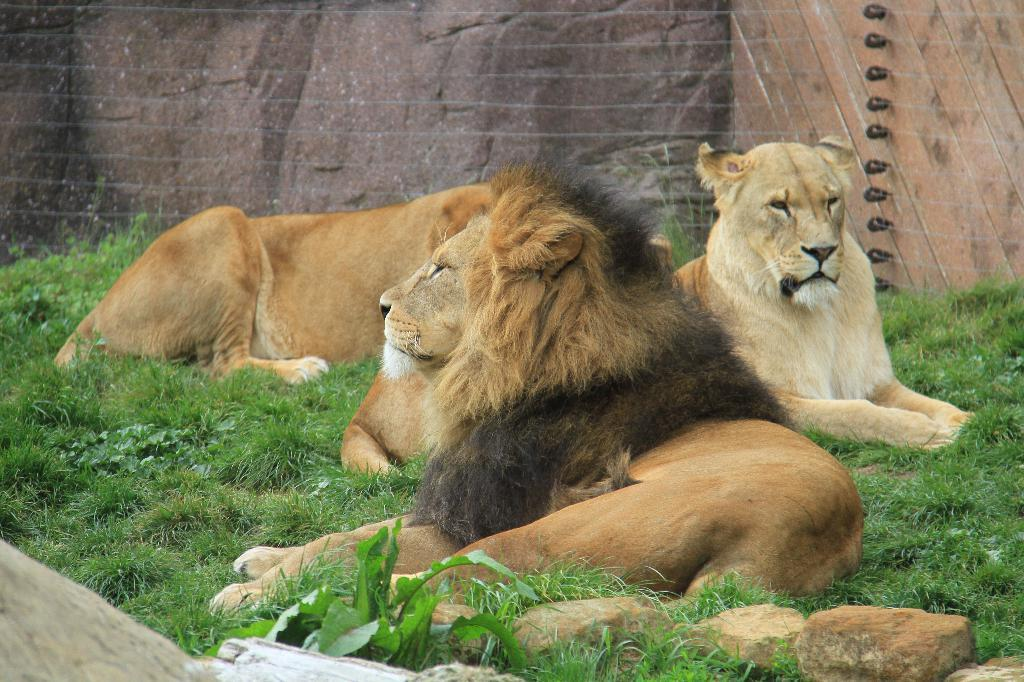What animals are in the center of the image? There are lions in the center of the image. What is the lions' location in relation to the ground? The lions are on the grass. What can be seen in the background of the image? There is a wall in the background of the image. What materials are present at the bottom of the image? Stones and wood are visible at the bottom of the image. What type of sink can be seen in the image? There is no sink present in the image; it features lions on the grass with a wall in the background and stones and wood at the bottom. 